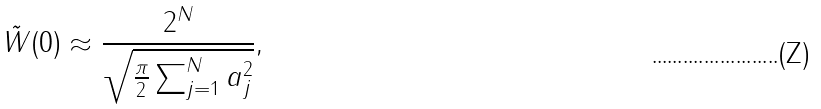Convert formula to latex. <formula><loc_0><loc_0><loc_500><loc_500>\tilde { W } ( 0 ) \approx \frac { 2 ^ { N } } { \sqrt { \frac { \pi } 2 \sum _ { j = 1 } ^ { N } a _ { j } ^ { 2 } } } ,</formula> 